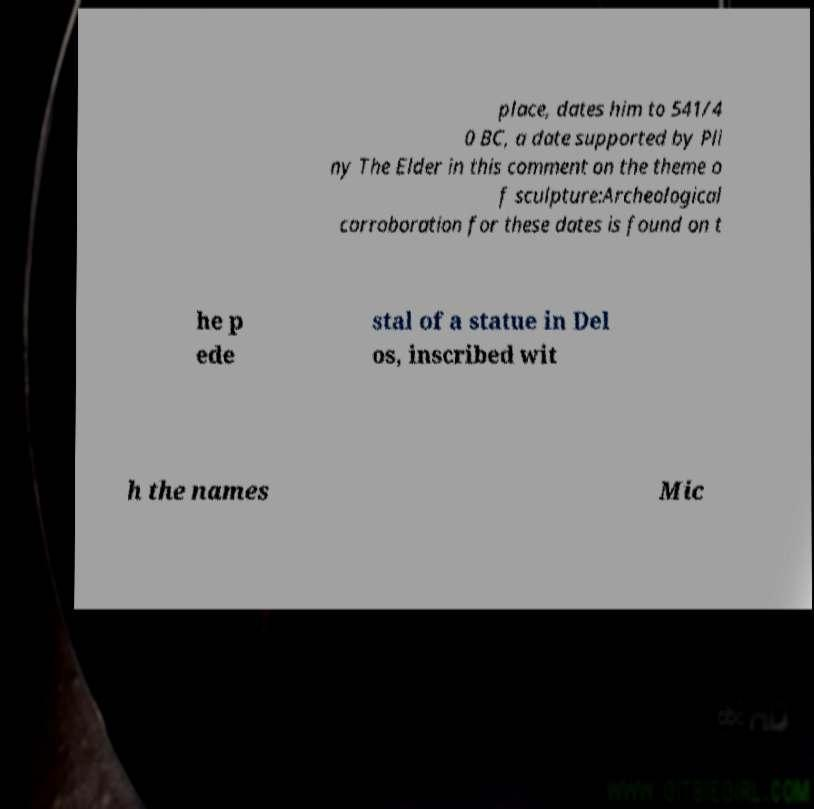I need the written content from this picture converted into text. Can you do that? place, dates him to 541/4 0 BC, a date supported by Pli ny The Elder in this comment on the theme o f sculpture:Archeological corroboration for these dates is found on t he p ede stal of a statue in Del os, inscribed wit h the names Mic 